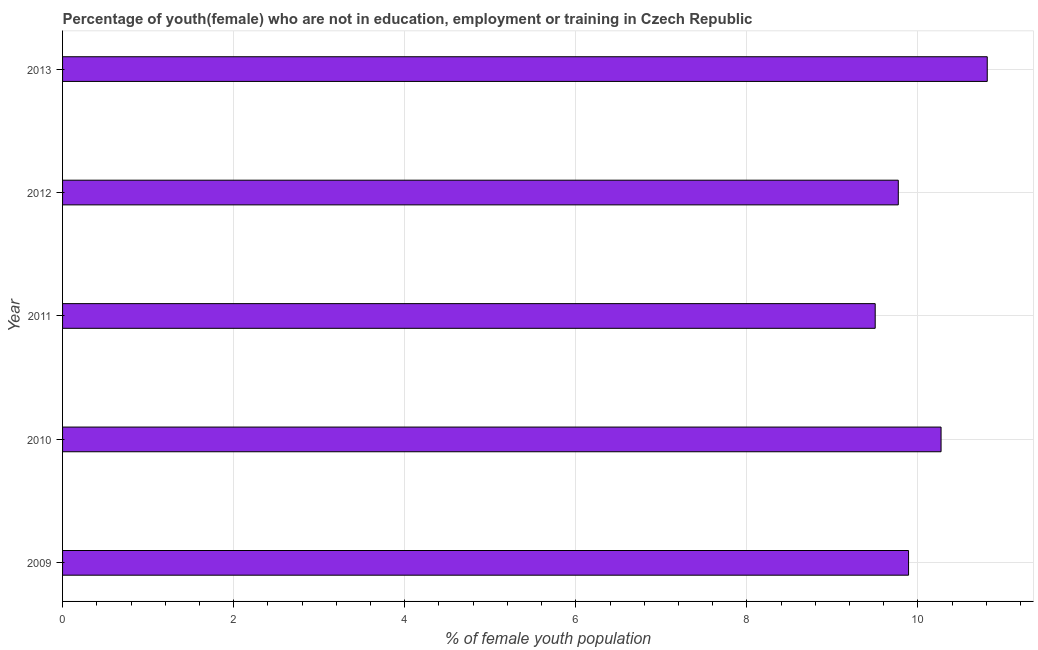Does the graph contain any zero values?
Make the answer very short. No. Does the graph contain grids?
Give a very brief answer. Yes. What is the title of the graph?
Your response must be concise. Percentage of youth(female) who are not in education, employment or training in Czech Republic. What is the label or title of the X-axis?
Ensure brevity in your answer.  % of female youth population. What is the label or title of the Y-axis?
Give a very brief answer. Year. What is the unemployed female youth population in 2009?
Ensure brevity in your answer.  9.89. Across all years, what is the maximum unemployed female youth population?
Provide a short and direct response. 10.81. In which year was the unemployed female youth population maximum?
Offer a very short reply. 2013. In which year was the unemployed female youth population minimum?
Keep it short and to the point. 2011. What is the sum of the unemployed female youth population?
Provide a succinct answer. 50.24. What is the difference between the unemployed female youth population in 2009 and 2011?
Your response must be concise. 0.39. What is the average unemployed female youth population per year?
Your response must be concise. 10.05. What is the median unemployed female youth population?
Your response must be concise. 9.89. In how many years, is the unemployed female youth population greater than 8.4 %?
Provide a short and direct response. 5. What is the ratio of the unemployed female youth population in 2009 to that in 2010?
Ensure brevity in your answer.  0.96. Is the unemployed female youth population in 2010 less than that in 2012?
Give a very brief answer. No. Is the difference between the unemployed female youth population in 2011 and 2012 greater than the difference between any two years?
Give a very brief answer. No. What is the difference between the highest and the second highest unemployed female youth population?
Provide a short and direct response. 0.54. What is the difference between the highest and the lowest unemployed female youth population?
Give a very brief answer. 1.31. In how many years, is the unemployed female youth population greater than the average unemployed female youth population taken over all years?
Your answer should be very brief. 2. How many years are there in the graph?
Keep it short and to the point. 5. What is the difference between two consecutive major ticks on the X-axis?
Provide a short and direct response. 2. What is the % of female youth population in 2009?
Give a very brief answer. 9.89. What is the % of female youth population in 2010?
Give a very brief answer. 10.27. What is the % of female youth population of 2012?
Provide a succinct answer. 9.77. What is the % of female youth population in 2013?
Provide a succinct answer. 10.81. What is the difference between the % of female youth population in 2009 and 2010?
Ensure brevity in your answer.  -0.38. What is the difference between the % of female youth population in 2009 and 2011?
Keep it short and to the point. 0.39. What is the difference between the % of female youth population in 2009 and 2012?
Provide a short and direct response. 0.12. What is the difference between the % of female youth population in 2009 and 2013?
Provide a succinct answer. -0.92. What is the difference between the % of female youth population in 2010 and 2011?
Keep it short and to the point. 0.77. What is the difference between the % of female youth population in 2010 and 2013?
Ensure brevity in your answer.  -0.54. What is the difference between the % of female youth population in 2011 and 2012?
Offer a very short reply. -0.27. What is the difference between the % of female youth population in 2011 and 2013?
Your response must be concise. -1.31. What is the difference between the % of female youth population in 2012 and 2013?
Provide a short and direct response. -1.04. What is the ratio of the % of female youth population in 2009 to that in 2011?
Make the answer very short. 1.04. What is the ratio of the % of female youth population in 2009 to that in 2013?
Your answer should be compact. 0.92. What is the ratio of the % of female youth population in 2010 to that in 2011?
Your answer should be very brief. 1.08. What is the ratio of the % of female youth population in 2010 to that in 2012?
Keep it short and to the point. 1.05. What is the ratio of the % of female youth population in 2011 to that in 2013?
Your answer should be compact. 0.88. What is the ratio of the % of female youth population in 2012 to that in 2013?
Ensure brevity in your answer.  0.9. 